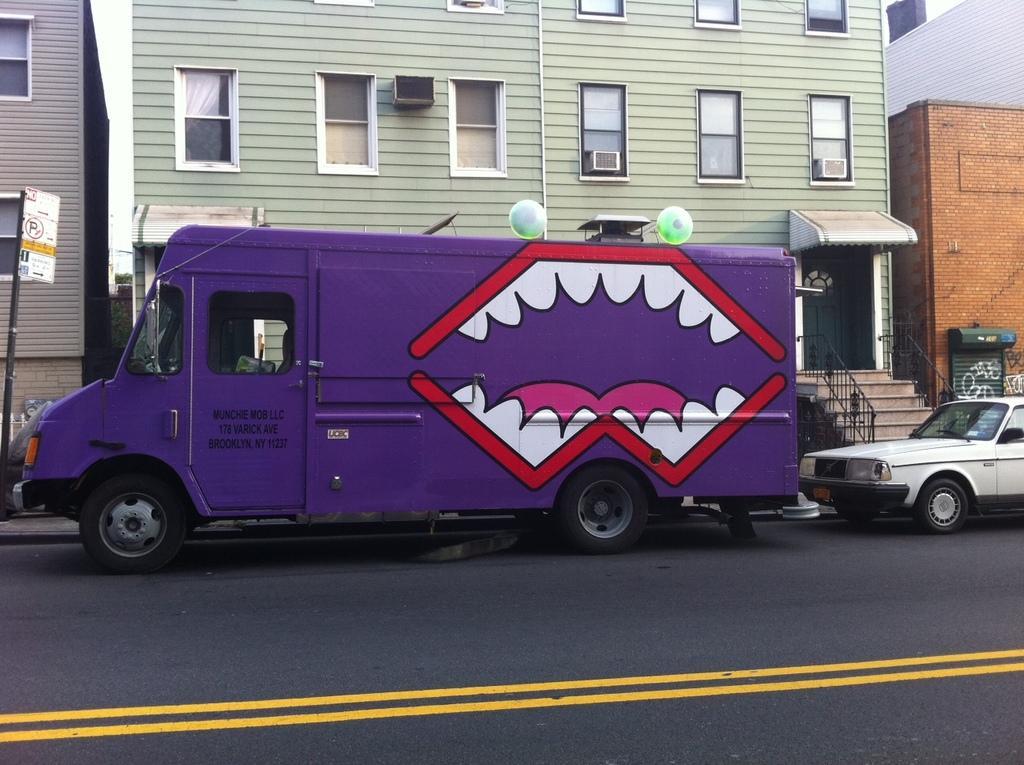Please provide a concise description of this image. As we can see in the image there is a purple color truck, white color car, stairs, buildings, windows and banner. 